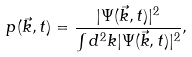<formula> <loc_0><loc_0><loc_500><loc_500>p ( \vec { k } , t ) = \frac { | \Psi ( \vec { k } , t ) | ^ { 2 } } { \int d ^ { 2 } k | \Psi ( \vec { k } , t ) | ^ { 2 } } ,</formula> 